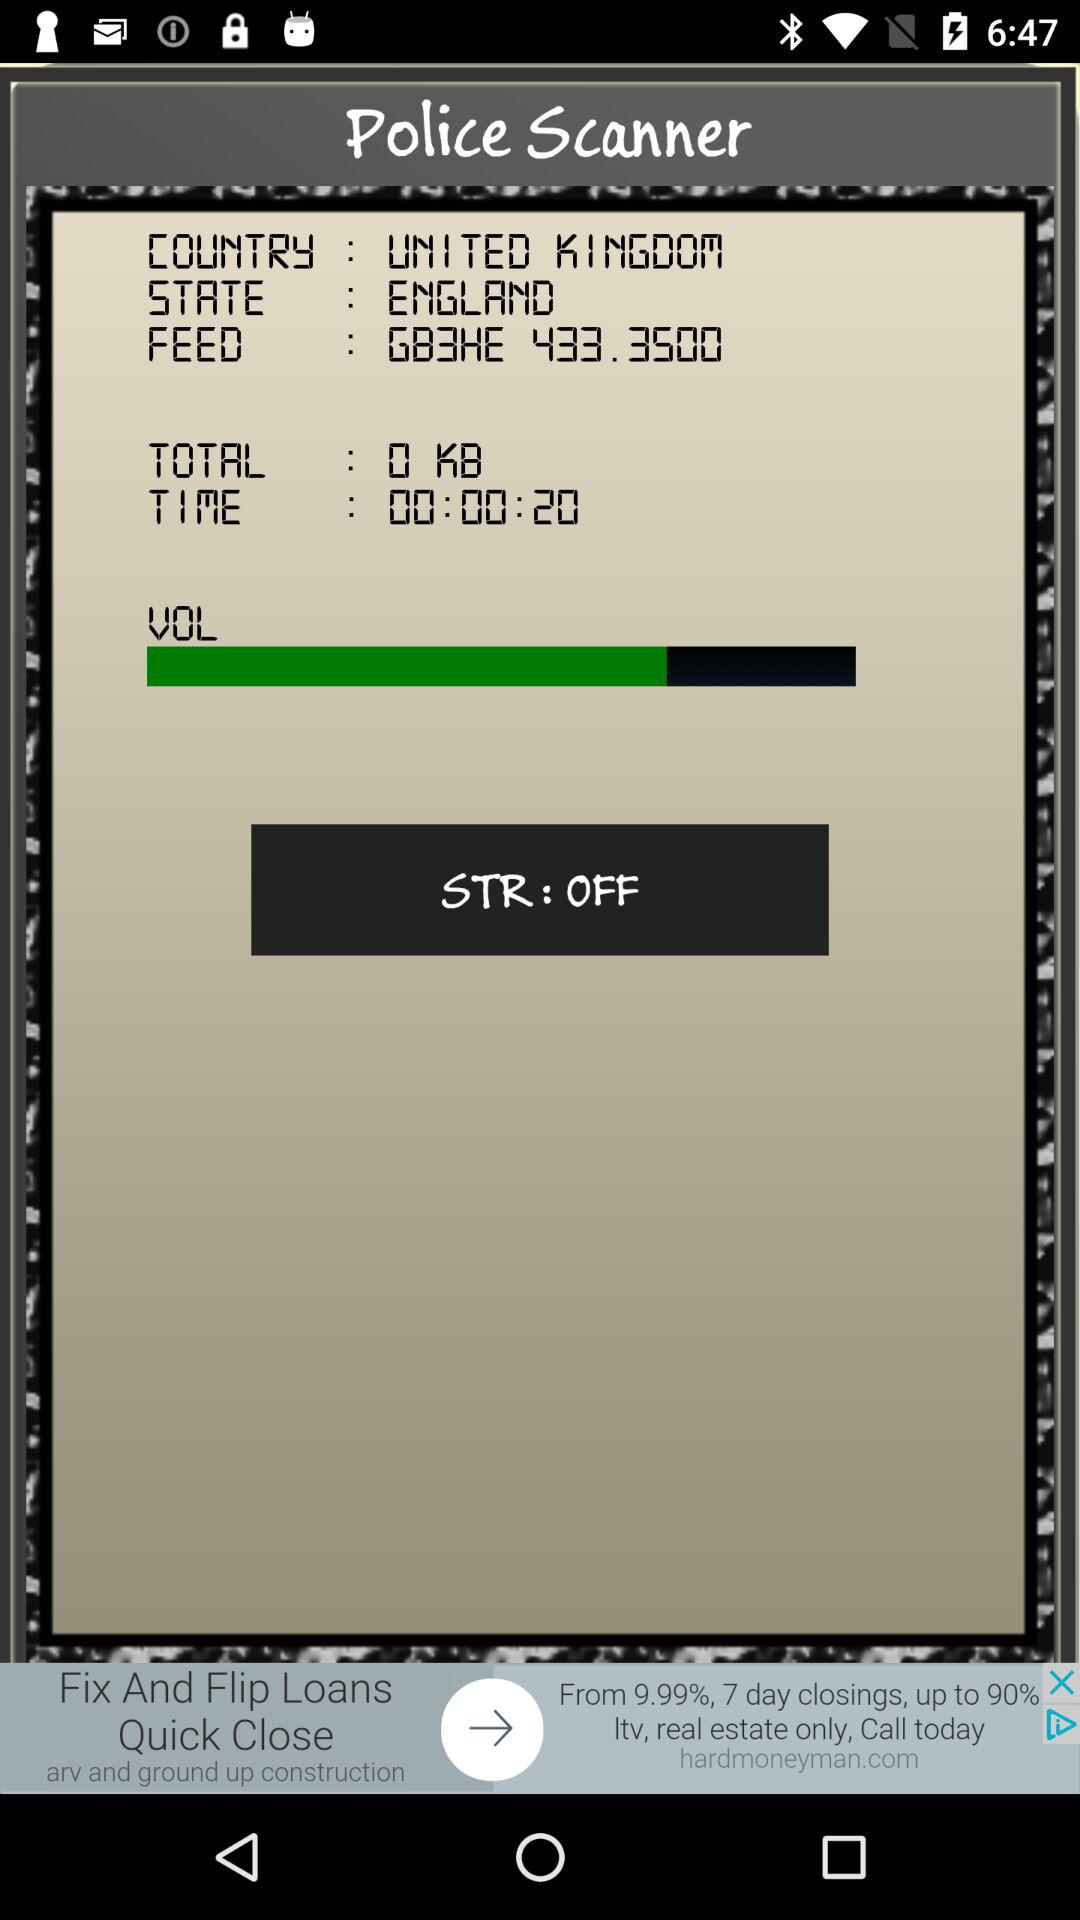What is the application name? The application name is "Police Scanner". 